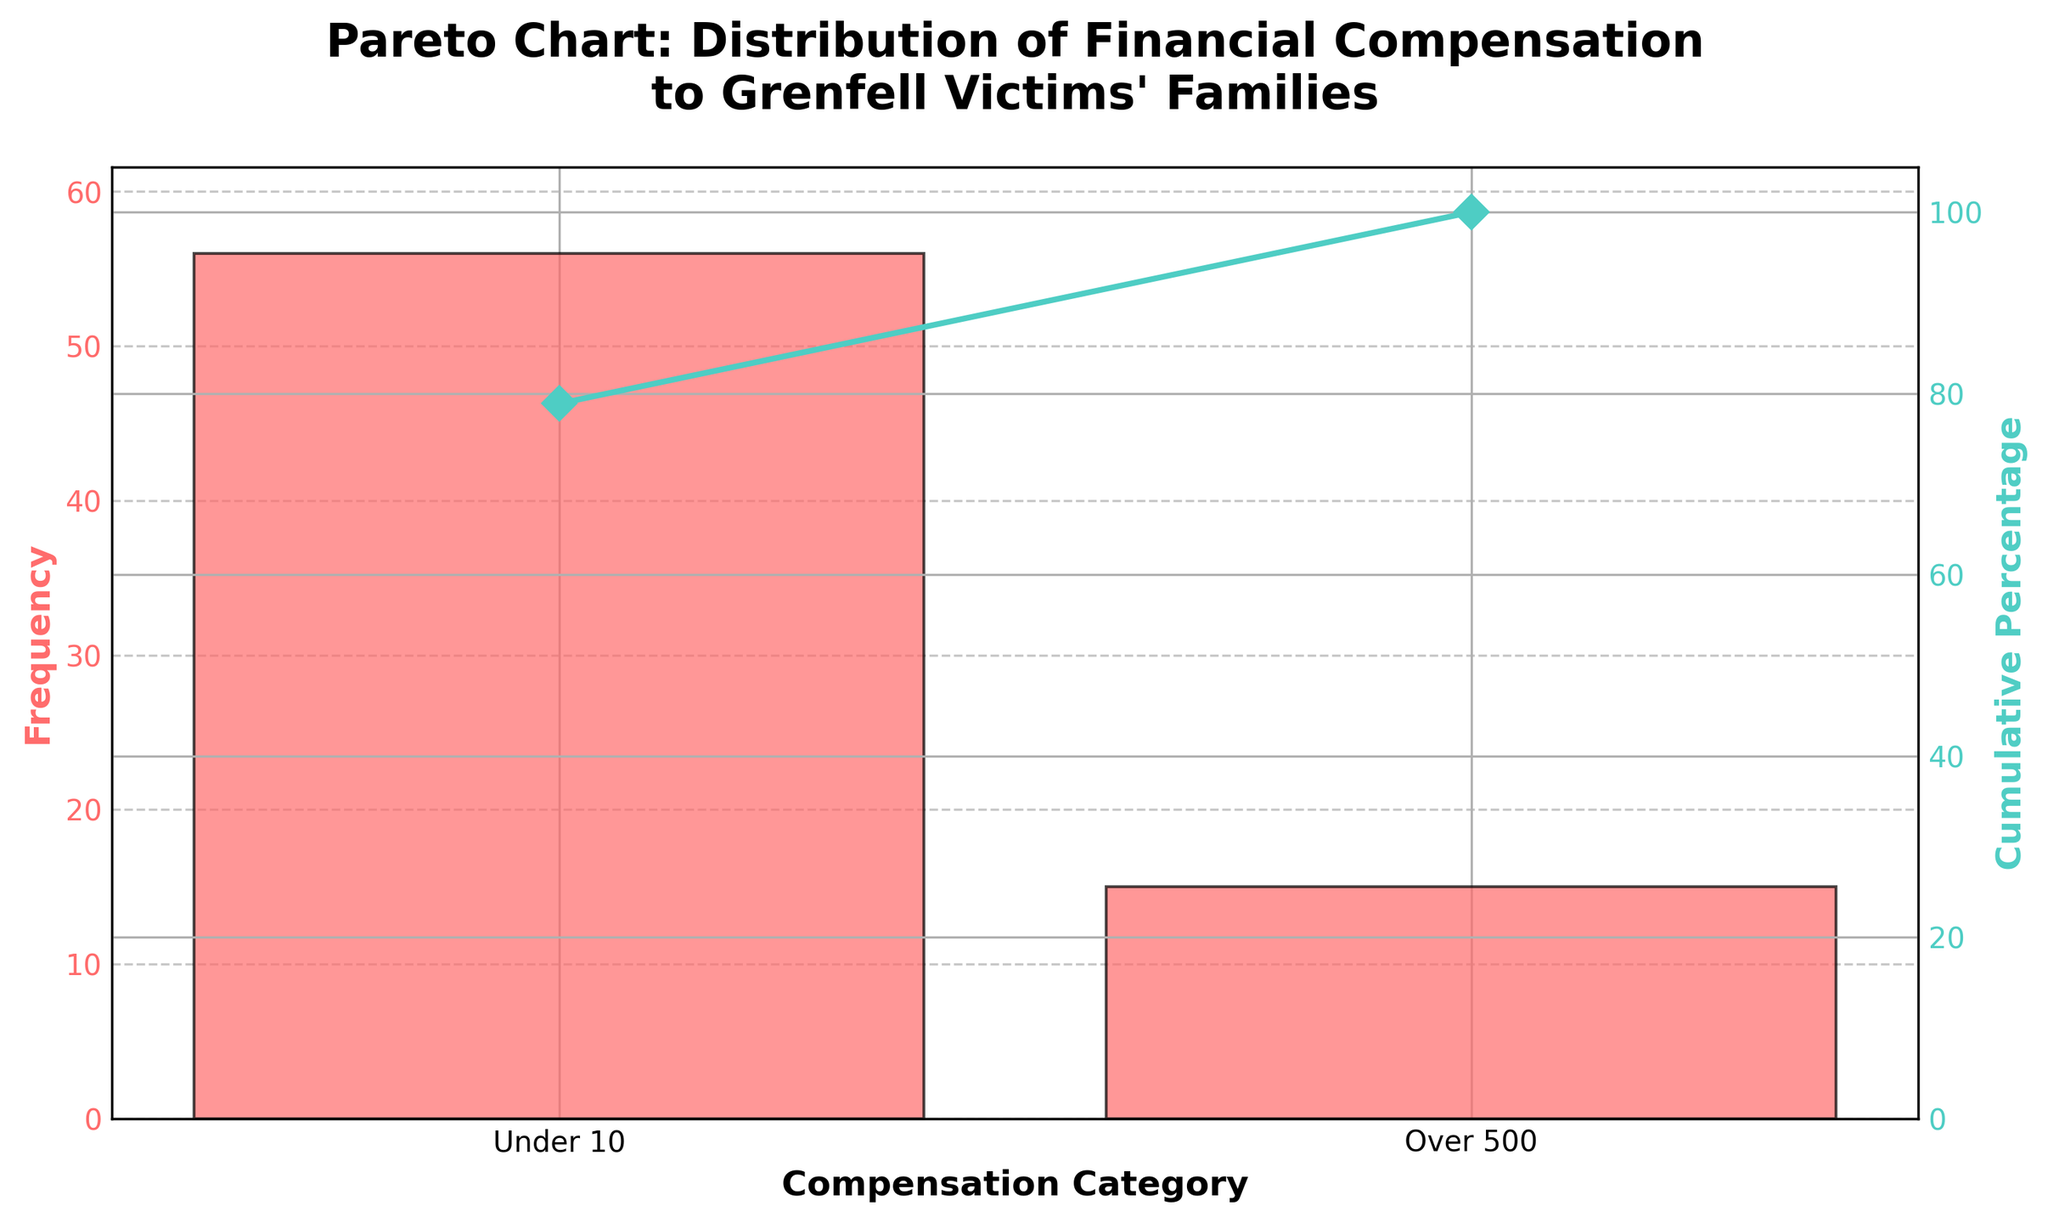Which compensation category has the highest frequency? Based on the height of the bars in the bar chart, the "Under 10,000" category has the highest frequency.
Answer: Under 10,000 What is the title of the chart? The title of the chart is located at the top and reads, "Pareto Chart: Distribution of Financial Compensation to Grenfell Victims' Families."
Answer: Pareto Chart: Distribution of Financial Compensation to Grenfell Victims' Families What is the cumulative percentage for the "Under 10,000" compensation category? Look at the line plot representing cumulative percentage and read the value corresponding to the "Under 10,000" category.
Answer: 100% Which axis represents the frequency and which represents the cumulative percentage? The primary y-axis on the left represents the frequency, as indicated by the label "Frequency." The secondary y-axis on the right represents the cumulative percentage, labeled "Cumulative Percentage."
Answer: The left axis represents frequency and the right axis represents cumulative percentage What colors are used for the bars and the cumulative percentage line? The bars are shown in a reddish color, and the cumulative percentage line is in a teal color.
Answer: Reddish for bars and teal for the cumulative percentage line How many data points are there in the chart? There are two bars in the chart, indicating two data points for the compensation categories.
Answer: 2 What is the frequency difference between the "Over 500,000" and "Under 10,000" compensation categories? The frequency for "Under 10,000" is 56 and for "Over 500,000" is 15. The difference is 56 - 15.
Answer: 41 What cumulative percentage does the "Over 500,000" category represent alone? Look at the first data point in the cumulative percentage line, which represents "Over 500,000."
Answer: 21.13% What is the frequency ratio between "Under 10,000" and "Over 500,000"? The frequency of "Under 10,000" is 56 and "Over 500,000" is 15. The ratio is 56/15.
Answer: 3.73 Which category contributes more to the overall frequency? Comparing the bars' heights, the "Under 10,000" category has a higher frequency than the "Over 500,000" category.
Answer: Under 10,000 